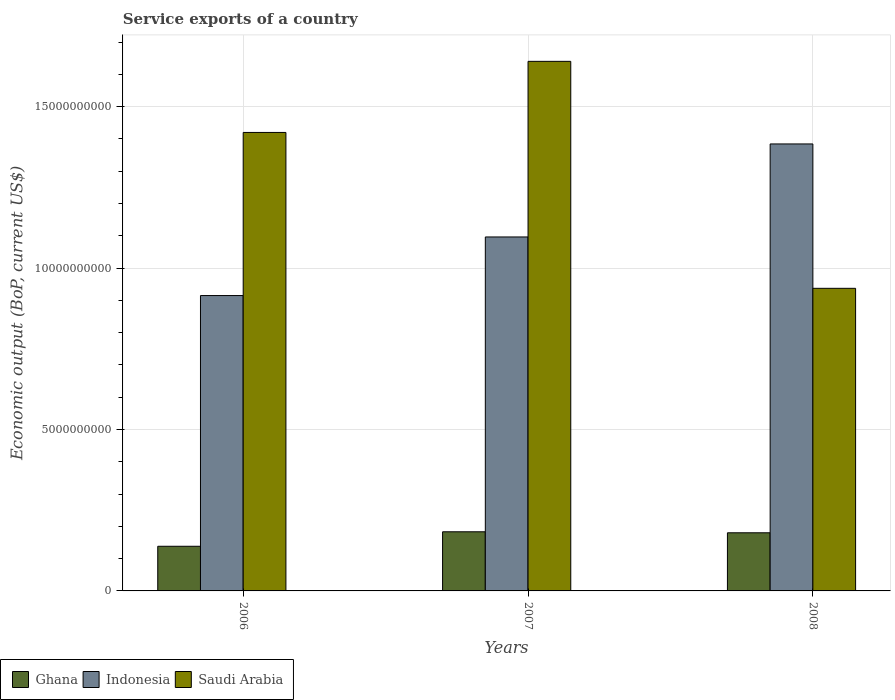How many groups of bars are there?
Offer a very short reply. 3. How many bars are there on the 1st tick from the right?
Give a very brief answer. 3. What is the label of the 1st group of bars from the left?
Your response must be concise. 2006. What is the service exports in Ghana in 2006?
Offer a very short reply. 1.38e+09. Across all years, what is the maximum service exports in Saudi Arabia?
Your answer should be very brief. 1.64e+1. Across all years, what is the minimum service exports in Saudi Arabia?
Ensure brevity in your answer.  9.37e+09. In which year was the service exports in Ghana maximum?
Give a very brief answer. 2007. In which year was the service exports in Indonesia minimum?
Your answer should be compact. 2006. What is the total service exports in Indonesia in the graph?
Provide a short and direct response. 3.40e+1. What is the difference between the service exports in Indonesia in 2006 and that in 2007?
Make the answer very short. -1.82e+09. What is the difference between the service exports in Ghana in 2008 and the service exports in Indonesia in 2006?
Make the answer very short. -7.35e+09. What is the average service exports in Indonesia per year?
Provide a succinct answer. 1.13e+1. In the year 2006, what is the difference between the service exports in Indonesia and service exports in Ghana?
Offer a terse response. 7.77e+09. What is the ratio of the service exports in Saudi Arabia in 2006 to that in 2007?
Your answer should be very brief. 0.87. Is the difference between the service exports in Indonesia in 2006 and 2007 greater than the difference between the service exports in Ghana in 2006 and 2007?
Offer a very short reply. No. What is the difference between the highest and the second highest service exports in Indonesia?
Offer a terse response. 2.88e+09. What is the difference between the highest and the lowest service exports in Indonesia?
Your response must be concise. 4.70e+09. In how many years, is the service exports in Ghana greater than the average service exports in Ghana taken over all years?
Give a very brief answer. 2. What does the 1st bar from the left in 2007 represents?
Provide a succinct answer. Ghana. What does the 3rd bar from the right in 2006 represents?
Keep it short and to the point. Ghana. Is it the case that in every year, the sum of the service exports in Saudi Arabia and service exports in Indonesia is greater than the service exports in Ghana?
Provide a short and direct response. Yes. How many years are there in the graph?
Offer a very short reply. 3. Are the values on the major ticks of Y-axis written in scientific E-notation?
Your answer should be very brief. No. Where does the legend appear in the graph?
Offer a very short reply. Bottom left. What is the title of the graph?
Your answer should be very brief. Service exports of a country. Does "Lao PDR" appear as one of the legend labels in the graph?
Provide a succinct answer. No. What is the label or title of the X-axis?
Make the answer very short. Years. What is the label or title of the Y-axis?
Keep it short and to the point. Economic output (BoP, current US$). What is the Economic output (BoP, current US$) of Ghana in 2006?
Your answer should be compact. 1.38e+09. What is the Economic output (BoP, current US$) in Indonesia in 2006?
Give a very brief answer. 9.15e+09. What is the Economic output (BoP, current US$) in Saudi Arabia in 2006?
Offer a terse response. 1.42e+1. What is the Economic output (BoP, current US$) in Ghana in 2007?
Provide a succinct answer. 1.83e+09. What is the Economic output (BoP, current US$) of Indonesia in 2007?
Give a very brief answer. 1.10e+1. What is the Economic output (BoP, current US$) in Saudi Arabia in 2007?
Your answer should be compact. 1.64e+1. What is the Economic output (BoP, current US$) of Ghana in 2008?
Provide a short and direct response. 1.80e+09. What is the Economic output (BoP, current US$) in Indonesia in 2008?
Your response must be concise. 1.38e+1. What is the Economic output (BoP, current US$) in Saudi Arabia in 2008?
Your answer should be very brief. 9.37e+09. Across all years, what is the maximum Economic output (BoP, current US$) in Ghana?
Offer a very short reply. 1.83e+09. Across all years, what is the maximum Economic output (BoP, current US$) in Indonesia?
Your answer should be very brief. 1.38e+1. Across all years, what is the maximum Economic output (BoP, current US$) of Saudi Arabia?
Your answer should be very brief. 1.64e+1. Across all years, what is the minimum Economic output (BoP, current US$) of Ghana?
Provide a short and direct response. 1.38e+09. Across all years, what is the minimum Economic output (BoP, current US$) in Indonesia?
Provide a succinct answer. 9.15e+09. Across all years, what is the minimum Economic output (BoP, current US$) of Saudi Arabia?
Keep it short and to the point. 9.37e+09. What is the total Economic output (BoP, current US$) in Ghana in the graph?
Provide a succinct answer. 5.02e+09. What is the total Economic output (BoP, current US$) of Indonesia in the graph?
Provide a succinct answer. 3.40e+1. What is the total Economic output (BoP, current US$) in Saudi Arabia in the graph?
Your answer should be compact. 4.00e+1. What is the difference between the Economic output (BoP, current US$) of Ghana in 2006 and that in 2007?
Your answer should be compact. -4.49e+08. What is the difference between the Economic output (BoP, current US$) in Indonesia in 2006 and that in 2007?
Your answer should be compact. -1.82e+09. What is the difference between the Economic output (BoP, current US$) of Saudi Arabia in 2006 and that in 2007?
Your answer should be compact. -2.20e+09. What is the difference between the Economic output (BoP, current US$) in Ghana in 2006 and that in 2008?
Offer a very short reply. -4.18e+08. What is the difference between the Economic output (BoP, current US$) of Indonesia in 2006 and that in 2008?
Provide a succinct answer. -4.70e+09. What is the difference between the Economic output (BoP, current US$) in Saudi Arabia in 2006 and that in 2008?
Your answer should be compact. 4.83e+09. What is the difference between the Economic output (BoP, current US$) in Ghana in 2007 and that in 2008?
Provide a short and direct response. 3.10e+07. What is the difference between the Economic output (BoP, current US$) in Indonesia in 2007 and that in 2008?
Provide a short and direct response. -2.88e+09. What is the difference between the Economic output (BoP, current US$) in Saudi Arabia in 2007 and that in 2008?
Your answer should be very brief. 7.03e+09. What is the difference between the Economic output (BoP, current US$) of Ghana in 2006 and the Economic output (BoP, current US$) of Indonesia in 2007?
Offer a very short reply. -9.58e+09. What is the difference between the Economic output (BoP, current US$) of Ghana in 2006 and the Economic output (BoP, current US$) of Saudi Arabia in 2007?
Ensure brevity in your answer.  -1.50e+1. What is the difference between the Economic output (BoP, current US$) in Indonesia in 2006 and the Economic output (BoP, current US$) in Saudi Arabia in 2007?
Offer a very short reply. -7.25e+09. What is the difference between the Economic output (BoP, current US$) in Ghana in 2006 and the Economic output (BoP, current US$) in Indonesia in 2008?
Keep it short and to the point. -1.25e+1. What is the difference between the Economic output (BoP, current US$) of Ghana in 2006 and the Economic output (BoP, current US$) of Saudi Arabia in 2008?
Your answer should be very brief. -7.99e+09. What is the difference between the Economic output (BoP, current US$) in Indonesia in 2006 and the Economic output (BoP, current US$) in Saudi Arabia in 2008?
Give a very brief answer. -2.24e+08. What is the difference between the Economic output (BoP, current US$) in Ghana in 2007 and the Economic output (BoP, current US$) in Indonesia in 2008?
Your response must be concise. -1.20e+1. What is the difference between the Economic output (BoP, current US$) of Ghana in 2007 and the Economic output (BoP, current US$) of Saudi Arabia in 2008?
Make the answer very short. -7.54e+09. What is the difference between the Economic output (BoP, current US$) of Indonesia in 2007 and the Economic output (BoP, current US$) of Saudi Arabia in 2008?
Keep it short and to the point. 1.59e+09. What is the average Economic output (BoP, current US$) of Ghana per year?
Provide a succinct answer. 1.67e+09. What is the average Economic output (BoP, current US$) of Indonesia per year?
Provide a succinct answer. 1.13e+1. What is the average Economic output (BoP, current US$) in Saudi Arabia per year?
Make the answer very short. 1.33e+1. In the year 2006, what is the difference between the Economic output (BoP, current US$) in Ghana and Economic output (BoP, current US$) in Indonesia?
Your answer should be compact. -7.77e+09. In the year 2006, what is the difference between the Economic output (BoP, current US$) in Ghana and Economic output (BoP, current US$) in Saudi Arabia?
Give a very brief answer. -1.28e+1. In the year 2006, what is the difference between the Economic output (BoP, current US$) in Indonesia and Economic output (BoP, current US$) in Saudi Arabia?
Offer a terse response. -5.05e+09. In the year 2007, what is the difference between the Economic output (BoP, current US$) of Ghana and Economic output (BoP, current US$) of Indonesia?
Your answer should be very brief. -9.13e+09. In the year 2007, what is the difference between the Economic output (BoP, current US$) in Ghana and Economic output (BoP, current US$) in Saudi Arabia?
Provide a short and direct response. -1.46e+1. In the year 2007, what is the difference between the Economic output (BoP, current US$) of Indonesia and Economic output (BoP, current US$) of Saudi Arabia?
Ensure brevity in your answer.  -5.44e+09. In the year 2008, what is the difference between the Economic output (BoP, current US$) in Ghana and Economic output (BoP, current US$) in Indonesia?
Your answer should be compact. -1.20e+1. In the year 2008, what is the difference between the Economic output (BoP, current US$) in Ghana and Economic output (BoP, current US$) in Saudi Arabia?
Provide a short and direct response. -7.57e+09. In the year 2008, what is the difference between the Economic output (BoP, current US$) of Indonesia and Economic output (BoP, current US$) of Saudi Arabia?
Offer a terse response. 4.47e+09. What is the ratio of the Economic output (BoP, current US$) in Ghana in 2006 to that in 2007?
Your answer should be very brief. 0.75. What is the ratio of the Economic output (BoP, current US$) of Indonesia in 2006 to that in 2007?
Offer a terse response. 0.83. What is the ratio of the Economic output (BoP, current US$) in Saudi Arabia in 2006 to that in 2007?
Keep it short and to the point. 0.87. What is the ratio of the Economic output (BoP, current US$) of Ghana in 2006 to that in 2008?
Make the answer very short. 0.77. What is the ratio of the Economic output (BoP, current US$) of Indonesia in 2006 to that in 2008?
Provide a short and direct response. 0.66. What is the ratio of the Economic output (BoP, current US$) in Saudi Arabia in 2006 to that in 2008?
Provide a succinct answer. 1.52. What is the ratio of the Economic output (BoP, current US$) of Ghana in 2007 to that in 2008?
Make the answer very short. 1.02. What is the ratio of the Economic output (BoP, current US$) of Indonesia in 2007 to that in 2008?
Make the answer very short. 0.79. What is the ratio of the Economic output (BoP, current US$) of Saudi Arabia in 2007 to that in 2008?
Ensure brevity in your answer.  1.75. What is the difference between the highest and the second highest Economic output (BoP, current US$) of Ghana?
Provide a succinct answer. 3.10e+07. What is the difference between the highest and the second highest Economic output (BoP, current US$) in Indonesia?
Provide a short and direct response. 2.88e+09. What is the difference between the highest and the second highest Economic output (BoP, current US$) of Saudi Arabia?
Ensure brevity in your answer.  2.20e+09. What is the difference between the highest and the lowest Economic output (BoP, current US$) in Ghana?
Offer a terse response. 4.49e+08. What is the difference between the highest and the lowest Economic output (BoP, current US$) in Indonesia?
Your response must be concise. 4.70e+09. What is the difference between the highest and the lowest Economic output (BoP, current US$) in Saudi Arabia?
Provide a short and direct response. 7.03e+09. 